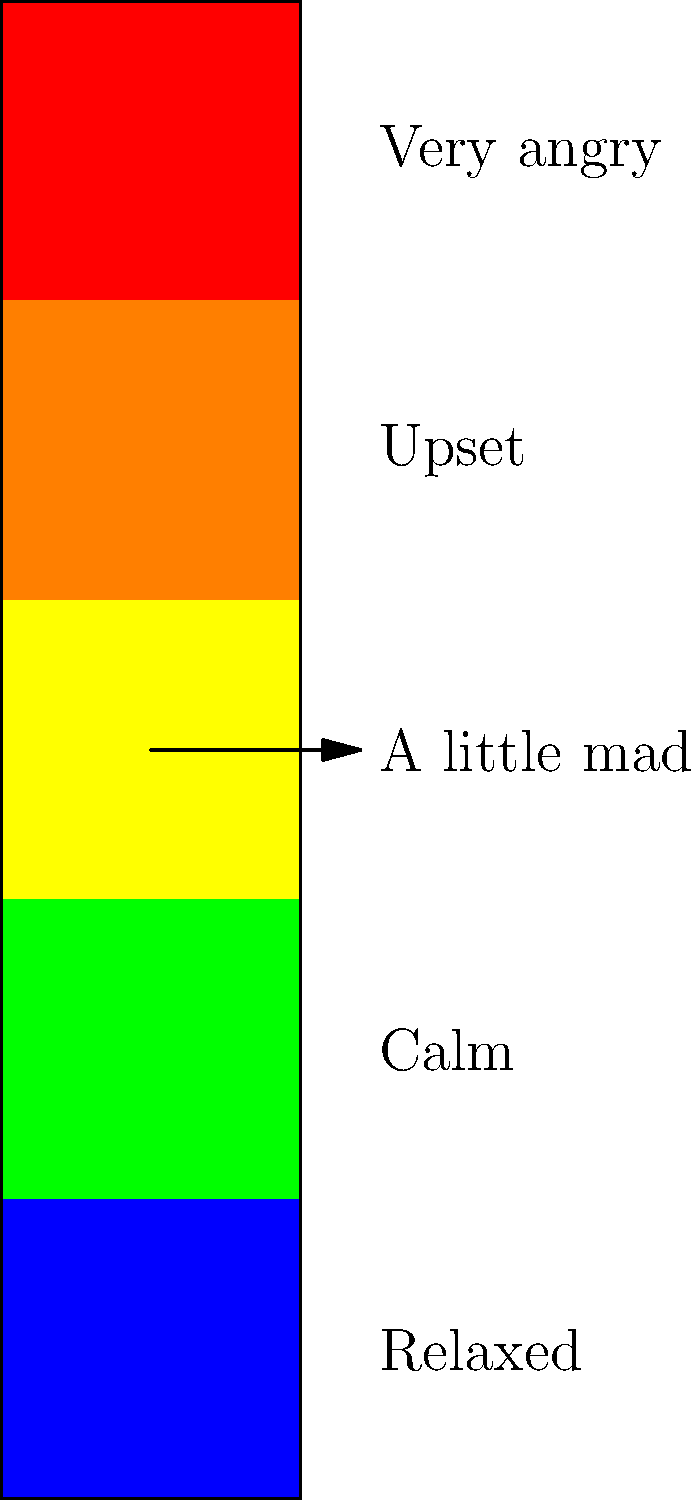Look at the emotion thermometer. If you're feeling "a little mad," which color would you point to on the thermometer? Let's look at the emotion thermometer step by step:

1. The thermometer is divided into five colors, from bottom to top: blue, green, yellow, orange, and red.
2. Each color represents a different level of emotional intensity:
   - Blue: Relaxed
   - Green: Calm
   - Yellow: A little mad
   - Orange: Upset
   - Red: Very angry
3. The question asks about feeling "a little mad."
4. On the thermometer, "A little mad" is labeled next to the yellow section.
5. Therefore, if you're feeling "a little mad," you would point to the yellow color on the thermometer.
Answer: Yellow 